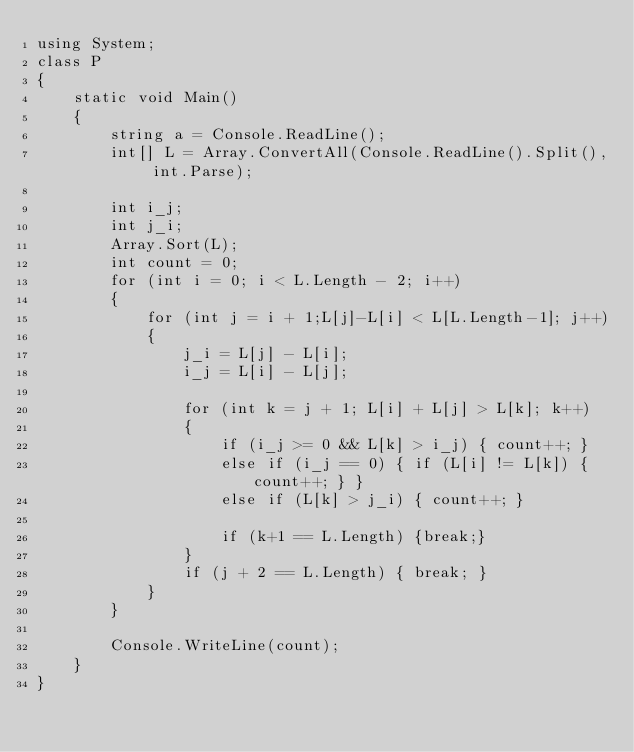<code> <loc_0><loc_0><loc_500><loc_500><_C#_>using System;
class P
{
    static void Main()
    {
        string a = Console.ReadLine();
        int[] L = Array.ConvertAll(Console.ReadLine().Split(), int.Parse);

        int i_j;
        int j_i;
        Array.Sort(L);
        int count = 0;
        for (int i = 0; i < L.Length - 2; i++)
        {
            for (int j = i + 1;L[j]-L[i] < L[L.Length-1]; j++)
            {
                j_i = L[j] - L[i];
                i_j = L[i] - L[j];

                for (int k = j + 1; L[i] + L[j] > L[k]; k++)
                {
                    if (i_j >= 0 && L[k] > i_j) { count++; }
                    else if (i_j == 0) { if (L[i] != L[k]) { count++; } }
                    else if (L[k] > j_i) { count++; }

                    if (k+1 == L.Length) {break;}
                }
                if (j + 2 == L.Length) { break; }
            }
        }

        Console.WriteLine(count);
    }
}</code> 